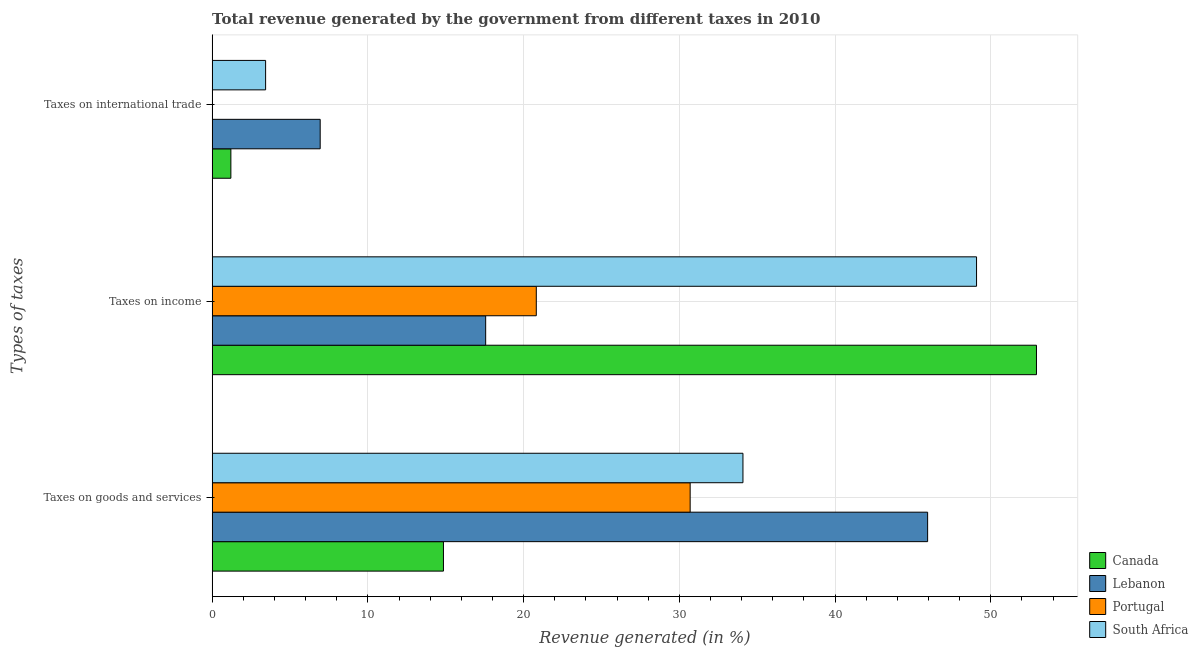Are the number of bars per tick equal to the number of legend labels?
Keep it short and to the point. Yes. How many bars are there on the 1st tick from the top?
Your answer should be very brief. 4. What is the label of the 1st group of bars from the top?
Your response must be concise. Taxes on international trade. What is the percentage of revenue generated by tax on international trade in South Africa?
Your answer should be compact. 3.43. Across all countries, what is the maximum percentage of revenue generated by tax on international trade?
Keep it short and to the point. 6.94. Across all countries, what is the minimum percentage of revenue generated by taxes on income?
Offer a terse response. 17.57. In which country was the percentage of revenue generated by taxes on income maximum?
Provide a short and direct response. Canada. In which country was the percentage of revenue generated by taxes on income minimum?
Offer a terse response. Lebanon. What is the total percentage of revenue generated by tax on international trade in the graph?
Offer a terse response. 11.58. What is the difference between the percentage of revenue generated by tax on international trade in Lebanon and that in Portugal?
Offer a terse response. 6.94. What is the difference between the percentage of revenue generated by taxes on goods and services in Portugal and the percentage of revenue generated by taxes on income in Lebanon?
Provide a short and direct response. 13.13. What is the average percentage of revenue generated by tax on international trade per country?
Provide a succinct answer. 2.89. What is the difference between the percentage of revenue generated by tax on international trade and percentage of revenue generated by taxes on goods and services in Lebanon?
Your answer should be very brief. -39.01. What is the ratio of the percentage of revenue generated by taxes on goods and services in Canada to that in Lebanon?
Offer a very short reply. 0.32. What is the difference between the highest and the second highest percentage of revenue generated by tax on international trade?
Ensure brevity in your answer.  3.5. What is the difference between the highest and the lowest percentage of revenue generated by taxes on goods and services?
Your answer should be compact. 31.09. Is the sum of the percentage of revenue generated by taxes on goods and services in Canada and Portugal greater than the maximum percentage of revenue generated by taxes on income across all countries?
Offer a terse response. No. What does the 1st bar from the top in Taxes on goods and services represents?
Provide a short and direct response. South Africa. Are all the bars in the graph horizontal?
Provide a succinct answer. Yes. What is the difference between two consecutive major ticks on the X-axis?
Keep it short and to the point. 10. Does the graph contain any zero values?
Keep it short and to the point. No. Where does the legend appear in the graph?
Ensure brevity in your answer.  Bottom right. How many legend labels are there?
Your response must be concise. 4. What is the title of the graph?
Provide a succinct answer. Total revenue generated by the government from different taxes in 2010. Does "Eritrea" appear as one of the legend labels in the graph?
Your response must be concise. No. What is the label or title of the X-axis?
Give a very brief answer. Revenue generated (in %). What is the label or title of the Y-axis?
Provide a succinct answer. Types of taxes. What is the Revenue generated (in %) of Canada in Taxes on goods and services?
Offer a very short reply. 14.85. What is the Revenue generated (in %) in Lebanon in Taxes on goods and services?
Make the answer very short. 45.95. What is the Revenue generated (in %) of Portugal in Taxes on goods and services?
Keep it short and to the point. 30.7. What is the Revenue generated (in %) of South Africa in Taxes on goods and services?
Ensure brevity in your answer.  34.09. What is the Revenue generated (in %) in Canada in Taxes on income?
Give a very brief answer. 52.94. What is the Revenue generated (in %) of Lebanon in Taxes on income?
Ensure brevity in your answer.  17.57. What is the Revenue generated (in %) of Portugal in Taxes on income?
Offer a terse response. 20.82. What is the Revenue generated (in %) in South Africa in Taxes on income?
Provide a short and direct response. 49.09. What is the Revenue generated (in %) of Canada in Taxes on international trade?
Offer a very short reply. 1.2. What is the Revenue generated (in %) of Lebanon in Taxes on international trade?
Provide a succinct answer. 6.94. What is the Revenue generated (in %) of Portugal in Taxes on international trade?
Give a very brief answer. 0. What is the Revenue generated (in %) of South Africa in Taxes on international trade?
Ensure brevity in your answer.  3.43. Across all Types of taxes, what is the maximum Revenue generated (in %) of Canada?
Offer a very short reply. 52.94. Across all Types of taxes, what is the maximum Revenue generated (in %) of Lebanon?
Keep it short and to the point. 45.95. Across all Types of taxes, what is the maximum Revenue generated (in %) in Portugal?
Provide a short and direct response. 30.7. Across all Types of taxes, what is the maximum Revenue generated (in %) in South Africa?
Offer a terse response. 49.09. Across all Types of taxes, what is the minimum Revenue generated (in %) in Canada?
Ensure brevity in your answer.  1.2. Across all Types of taxes, what is the minimum Revenue generated (in %) in Lebanon?
Your response must be concise. 6.94. Across all Types of taxes, what is the minimum Revenue generated (in %) of Portugal?
Your response must be concise. 0. Across all Types of taxes, what is the minimum Revenue generated (in %) of South Africa?
Provide a short and direct response. 3.43. What is the total Revenue generated (in %) of Canada in the graph?
Your answer should be compact. 68.99. What is the total Revenue generated (in %) in Lebanon in the graph?
Your answer should be compact. 70.45. What is the total Revenue generated (in %) of Portugal in the graph?
Provide a short and direct response. 51.52. What is the total Revenue generated (in %) in South Africa in the graph?
Offer a very short reply. 86.61. What is the difference between the Revenue generated (in %) in Canada in Taxes on goods and services and that in Taxes on income?
Provide a succinct answer. -38.08. What is the difference between the Revenue generated (in %) of Lebanon in Taxes on goods and services and that in Taxes on income?
Provide a short and direct response. 28.38. What is the difference between the Revenue generated (in %) of Portugal in Taxes on goods and services and that in Taxes on income?
Ensure brevity in your answer.  9.88. What is the difference between the Revenue generated (in %) in South Africa in Taxes on goods and services and that in Taxes on income?
Make the answer very short. -15. What is the difference between the Revenue generated (in %) of Canada in Taxes on goods and services and that in Taxes on international trade?
Your response must be concise. 13.65. What is the difference between the Revenue generated (in %) in Lebanon in Taxes on goods and services and that in Taxes on international trade?
Provide a short and direct response. 39.01. What is the difference between the Revenue generated (in %) in Portugal in Taxes on goods and services and that in Taxes on international trade?
Make the answer very short. 30.7. What is the difference between the Revenue generated (in %) in South Africa in Taxes on goods and services and that in Taxes on international trade?
Give a very brief answer. 30.65. What is the difference between the Revenue generated (in %) of Canada in Taxes on income and that in Taxes on international trade?
Keep it short and to the point. 51.73. What is the difference between the Revenue generated (in %) in Lebanon in Taxes on income and that in Taxes on international trade?
Provide a short and direct response. 10.63. What is the difference between the Revenue generated (in %) in Portugal in Taxes on income and that in Taxes on international trade?
Keep it short and to the point. 20.82. What is the difference between the Revenue generated (in %) in South Africa in Taxes on income and that in Taxes on international trade?
Provide a short and direct response. 45.65. What is the difference between the Revenue generated (in %) in Canada in Taxes on goods and services and the Revenue generated (in %) in Lebanon in Taxes on income?
Offer a terse response. -2.71. What is the difference between the Revenue generated (in %) of Canada in Taxes on goods and services and the Revenue generated (in %) of Portugal in Taxes on income?
Offer a terse response. -5.96. What is the difference between the Revenue generated (in %) of Canada in Taxes on goods and services and the Revenue generated (in %) of South Africa in Taxes on income?
Make the answer very short. -34.23. What is the difference between the Revenue generated (in %) in Lebanon in Taxes on goods and services and the Revenue generated (in %) in Portugal in Taxes on income?
Provide a short and direct response. 25.13. What is the difference between the Revenue generated (in %) in Lebanon in Taxes on goods and services and the Revenue generated (in %) in South Africa in Taxes on income?
Your answer should be very brief. -3.14. What is the difference between the Revenue generated (in %) of Portugal in Taxes on goods and services and the Revenue generated (in %) of South Africa in Taxes on income?
Provide a succinct answer. -18.39. What is the difference between the Revenue generated (in %) in Canada in Taxes on goods and services and the Revenue generated (in %) in Lebanon in Taxes on international trade?
Offer a terse response. 7.92. What is the difference between the Revenue generated (in %) in Canada in Taxes on goods and services and the Revenue generated (in %) in Portugal in Taxes on international trade?
Offer a very short reply. 14.85. What is the difference between the Revenue generated (in %) in Canada in Taxes on goods and services and the Revenue generated (in %) in South Africa in Taxes on international trade?
Provide a short and direct response. 11.42. What is the difference between the Revenue generated (in %) in Lebanon in Taxes on goods and services and the Revenue generated (in %) in Portugal in Taxes on international trade?
Offer a very short reply. 45.94. What is the difference between the Revenue generated (in %) of Lebanon in Taxes on goods and services and the Revenue generated (in %) of South Africa in Taxes on international trade?
Offer a very short reply. 42.51. What is the difference between the Revenue generated (in %) of Portugal in Taxes on goods and services and the Revenue generated (in %) of South Africa in Taxes on international trade?
Make the answer very short. 27.26. What is the difference between the Revenue generated (in %) in Canada in Taxes on income and the Revenue generated (in %) in Lebanon in Taxes on international trade?
Keep it short and to the point. 46. What is the difference between the Revenue generated (in %) of Canada in Taxes on income and the Revenue generated (in %) of Portugal in Taxes on international trade?
Give a very brief answer. 52.93. What is the difference between the Revenue generated (in %) in Canada in Taxes on income and the Revenue generated (in %) in South Africa in Taxes on international trade?
Provide a short and direct response. 49.5. What is the difference between the Revenue generated (in %) of Lebanon in Taxes on income and the Revenue generated (in %) of Portugal in Taxes on international trade?
Your answer should be compact. 17.56. What is the difference between the Revenue generated (in %) in Lebanon in Taxes on income and the Revenue generated (in %) in South Africa in Taxes on international trade?
Your answer should be compact. 14.13. What is the difference between the Revenue generated (in %) of Portugal in Taxes on income and the Revenue generated (in %) of South Africa in Taxes on international trade?
Your answer should be compact. 17.38. What is the average Revenue generated (in %) in Canada per Types of taxes?
Your answer should be very brief. 23. What is the average Revenue generated (in %) in Lebanon per Types of taxes?
Make the answer very short. 23.48. What is the average Revenue generated (in %) in Portugal per Types of taxes?
Provide a short and direct response. 17.17. What is the average Revenue generated (in %) in South Africa per Types of taxes?
Provide a succinct answer. 28.87. What is the difference between the Revenue generated (in %) of Canada and Revenue generated (in %) of Lebanon in Taxes on goods and services?
Your answer should be compact. -31.09. What is the difference between the Revenue generated (in %) of Canada and Revenue generated (in %) of Portugal in Taxes on goods and services?
Your response must be concise. -15.84. What is the difference between the Revenue generated (in %) of Canada and Revenue generated (in %) of South Africa in Taxes on goods and services?
Provide a short and direct response. -19.23. What is the difference between the Revenue generated (in %) of Lebanon and Revenue generated (in %) of Portugal in Taxes on goods and services?
Offer a very short reply. 15.25. What is the difference between the Revenue generated (in %) of Lebanon and Revenue generated (in %) of South Africa in Taxes on goods and services?
Offer a very short reply. 11.86. What is the difference between the Revenue generated (in %) of Portugal and Revenue generated (in %) of South Africa in Taxes on goods and services?
Offer a very short reply. -3.39. What is the difference between the Revenue generated (in %) in Canada and Revenue generated (in %) in Lebanon in Taxes on income?
Provide a short and direct response. 35.37. What is the difference between the Revenue generated (in %) of Canada and Revenue generated (in %) of Portugal in Taxes on income?
Offer a terse response. 32.12. What is the difference between the Revenue generated (in %) in Canada and Revenue generated (in %) in South Africa in Taxes on income?
Provide a succinct answer. 3.85. What is the difference between the Revenue generated (in %) of Lebanon and Revenue generated (in %) of Portugal in Taxes on income?
Your answer should be compact. -3.25. What is the difference between the Revenue generated (in %) in Lebanon and Revenue generated (in %) in South Africa in Taxes on income?
Your response must be concise. -31.52. What is the difference between the Revenue generated (in %) in Portugal and Revenue generated (in %) in South Africa in Taxes on income?
Your answer should be compact. -28.27. What is the difference between the Revenue generated (in %) of Canada and Revenue generated (in %) of Lebanon in Taxes on international trade?
Provide a short and direct response. -5.74. What is the difference between the Revenue generated (in %) in Canada and Revenue generated (in %) in Portugal in Taxes on international trade?
Your response must be concise. 1.2. What is the difference between the Revenue generated (in %) of Canada and Revenue generated (in %) of South Africa in Taxes on international trade?
Provide a succinct answer. -2.23. What is the difference between the Revenue generated (in %) in Lebanon and Revenue generated (in %) in Portugal in Taxes on international trade?
Your answer should be very brief. 6.94. What is the difference between the Revenue generated (in %) in Lebanon and Revenue generated (in %) in South Africa in Taxes on international trade?
Keep it short and to the point. 3.5. What is the difference between the Revenue generated (in %) in Portugal and Revenue generated (in %) in South Africa in Taxes on international trade?
Make the answer very short. -3.43. What is the ratio of the Revenue generated (in %) in Canada in Taxes on goods and services to that in Taxes on income?
Ensure brevity in your answer.  0.28. What is the ratio of the Revenue generated (in %) in Lebanon in Taxes on goods and services to that in Taxes on income?
Your answer should be very brief. 2.62. What is the ratio of the Revenue generated (in %) of Portugal in Taxes on goods and services to that in Taxes on income?
Your answer should be very brief. 1.47. What is the ratio of the Revenue generated (in %) in South Africa in Taxes on goods and services to that in Taxes on income?
Make the answer very short. 0.69. What is the ratio of the Revenue generated (in %) of Canada in Taxes on goods and services to that in Taxes on international trade?
Make the answer very short. 12.34. What is the ratio of the Revenue generated (in %) in Lebanon in Taxes on goods and services to that in Taxes on international trade?
Provide a short and direct response. 6.62. What is the ratio of the Revenue generated (in %) in Portugal in Taxes on goods and services to that in Taxes on international trade?
Your answer should be compact. 1.88e+04. What is the ratio of the Revenue generated (in %) in South Africa in Taxes on goods and services to that in Taxes on international trade?
Offer a terse response. 9.92. What is the ratio of the Revenue generated (in %) of Canada in Taxes on income to that in Taxes on international trade?
Keep it short and to the point. 43.97. What is the ratio of the Revenue generated (in %) of Lebanon in Taxes on income to that in Taxes on international trade?
Offer a terse response. 2.53. What is the ratio of the Revenue generated (in %) in Portugal in Taxes on income to that in Taxes on international trade?
Offer a terse response. 1.27e+04. What is the ratio of the Revenue generated (in %) of South Africa in Taxes on income to that in Taxes on international trade?
Give a very brief answer. 14.29. What is the difference between the highest and the second highest Revenue generated (in %) in Canada?
Ensure brevity in your answer.  38.08. What is the difference between the highest and the second highest Revenue generated (in %) in Lebanon?
Your answer should be compact. 28.38. What is the difference between the highest and the second highest Revenue generated (in %) in Portugal?
Your answer should be compact. 9.88. What is the difference between the highest and the second highest Revenue generated (in %) in South Africa?
Your answer should be very brief. 15. What is the difference between the highest and the lowest Revenue generated (in %) in Canada?
Provide a short and direct response. 51.73. What is the difference between the highest and the lowest Revenue generated (in %) of Lebanon?
Your answer should be compact. 39.01. What is the difference between the highest and the lowest Revenue generated (in %) of Portugal?
Your answer should be very brief. 30.7. What is the difference between the highest and the lowest Revenue generated (in %) of South Africa?
Keep it short and to the point. 45.65. 